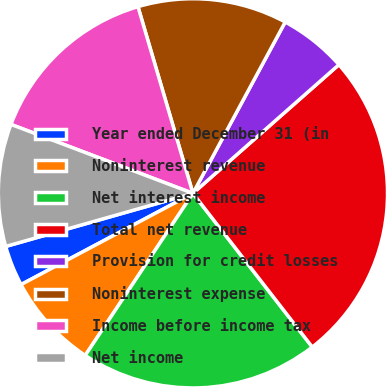Convert chart to OTSL. <chart><loc_0><loc_0><loc_500><loc_500><pie_chart><fcel>Year ended December 31 (in<fcel>Noninterest revenue<fcel>Net interest income<fcel>Total net revenue<fcel>Provision for credit losses<fcel>Noninterest expense<fcel>Income before income tax<fcel>Net income<nl><fcel>3.37%<fcel>7.9%<fcel>19.84%<fcel>25.99%<fcel>5.64%<fcel>12.42%<fcel>14.68%<fcel>10.16%<nl></chart> 